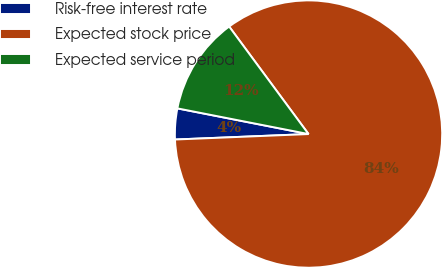<chart> <loc_0><loc_0><loc_500><loc_500><pie_chart><fcel>Risk-free interest rate<fcel>Expected stock price<fcel>Expected service period<nl><fcel>3.73%<fcel>84.47%<fcel>11.8%<nl></chart> 